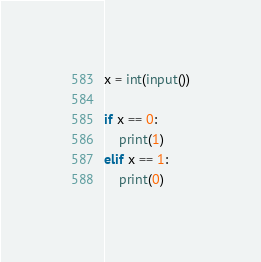<code> <loc_0><loc_0><loc_500><loc_500><_Python_>x = int(input())

if x == 0:
    print(1)
elif x == 1:
    print(0)</code> 